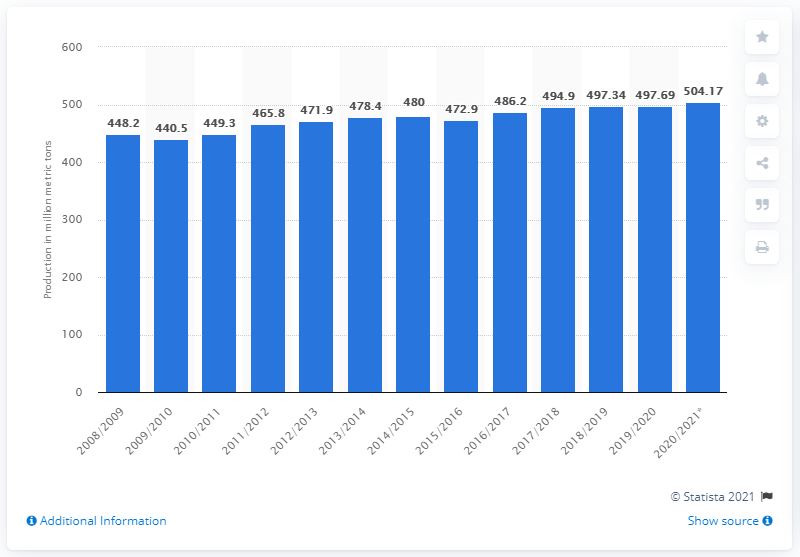Give some essential details in this illustration. The milled rice production volume in crop year 2008/2009 was 449.3. 